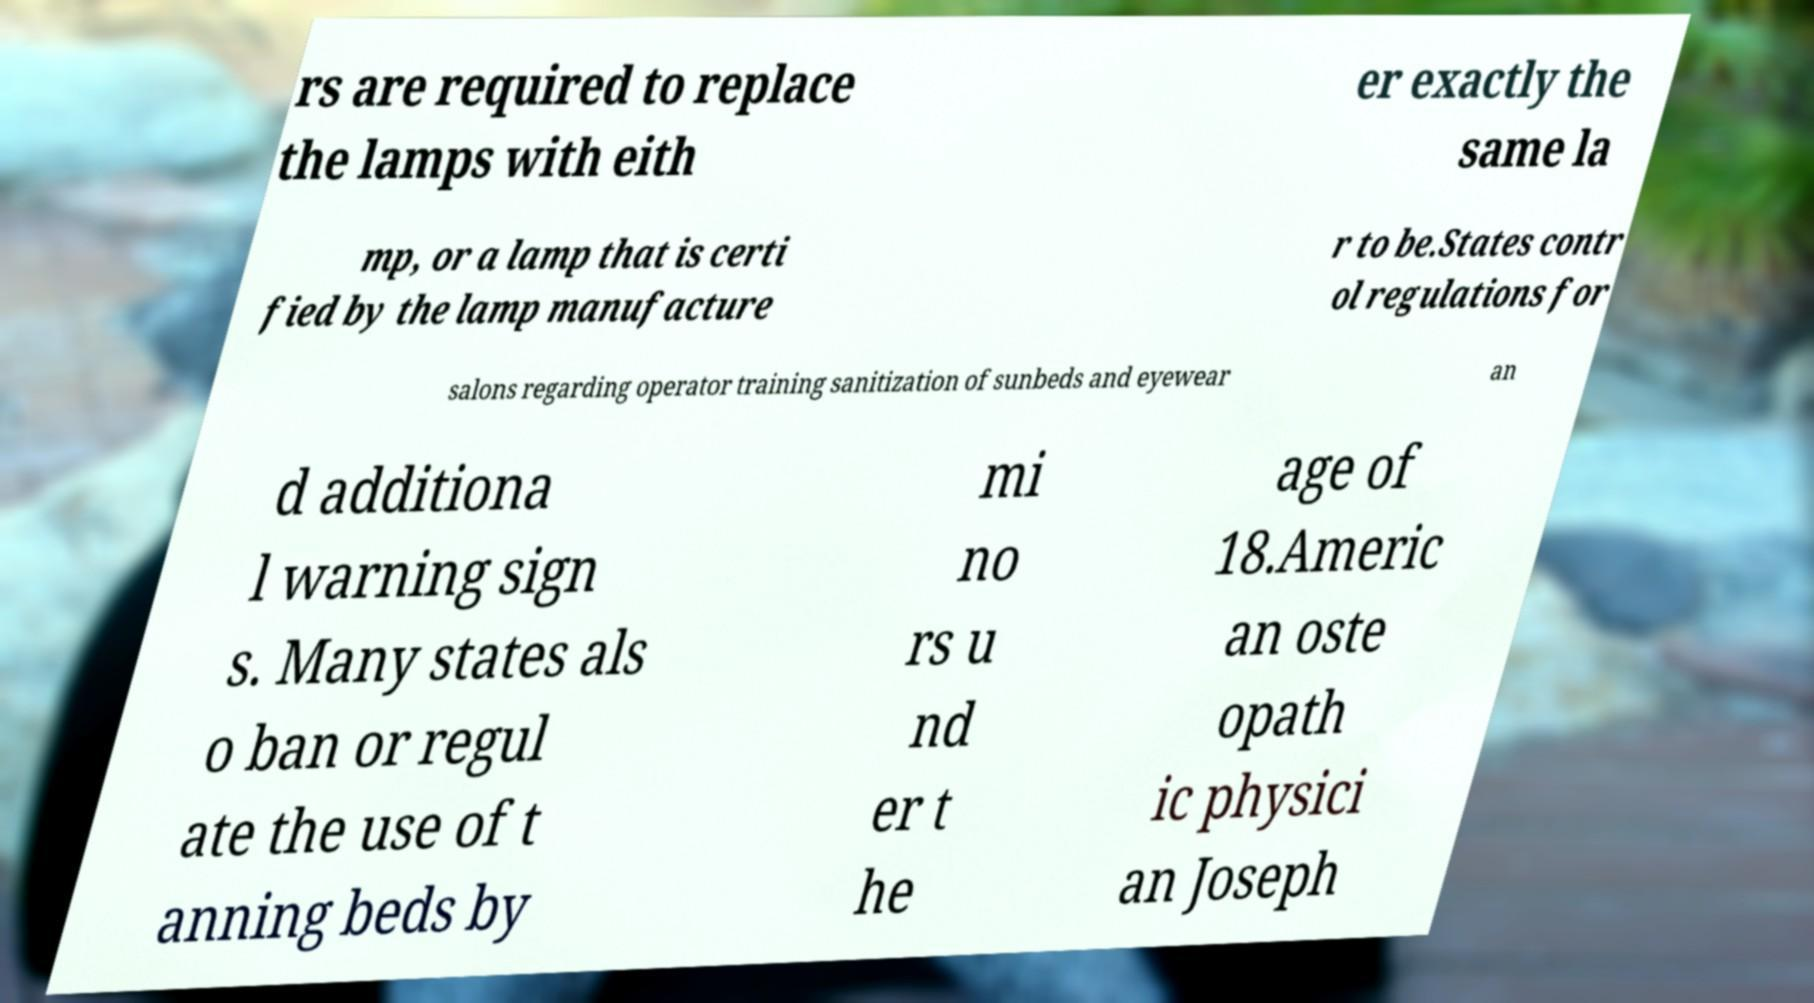Please identify and transcribe the text found in this image. rs are required to replace the lamps with eith er exactly the same la mp, or a lamp that is certi fied by the lamp manufacture r to be.States contr ol regulations for salons regarding operator training sanitization of sunbeds and eyewear an d additiona l warning sign s. Many states als o ban or regul ate the use of t anning beds by mi no rs u nd er t he age of 18.Americ an oste opath ic physici an Joseph 